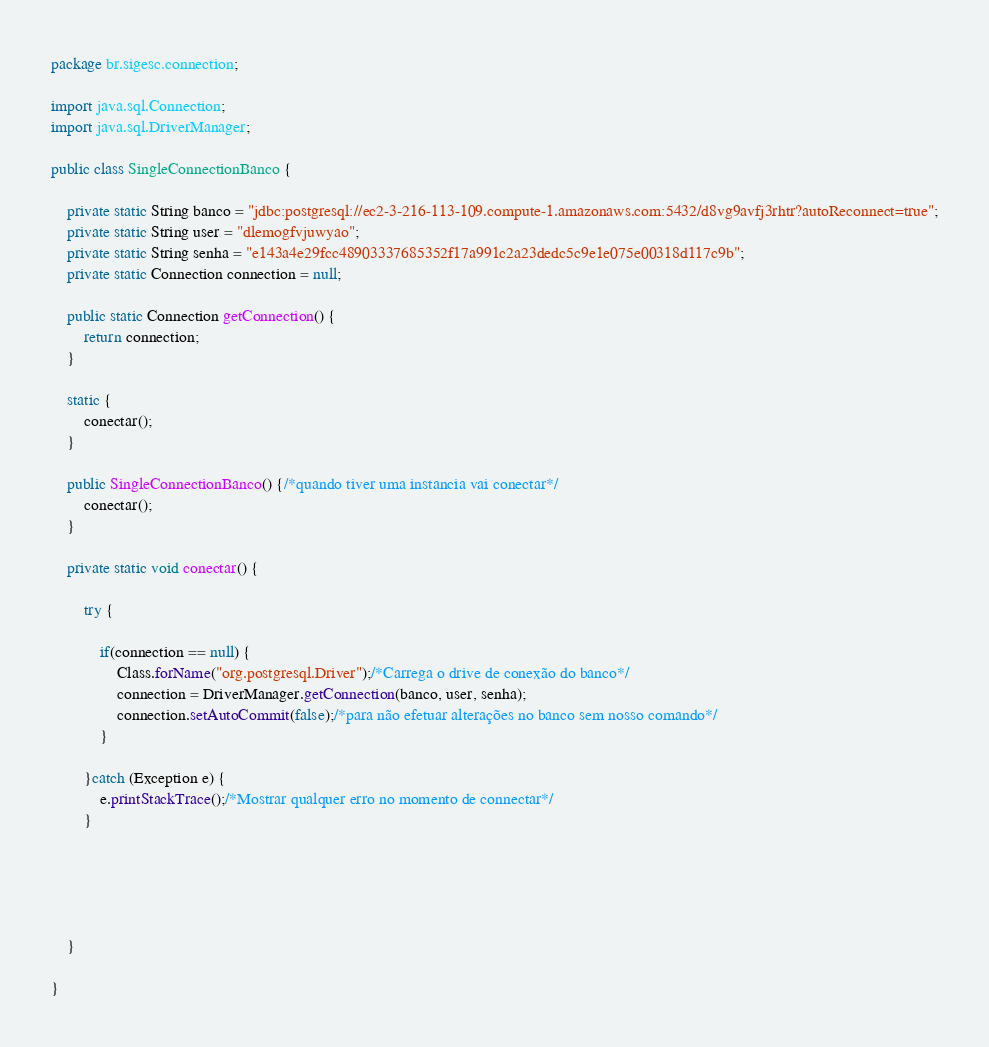<code> <loc_0><loc_0><loc_500><loc_500><_Java_>package br.sigesc.connection;

import java.sql.Connection;
import java.sql.DriverManager;

public class SingleConnectionBanco {
	
	private static String banco = "jdbc:postgresql://ec2-3-216-113-109.compute-1.amazonaws.com:5432/d8vg9avfj3rhtr?autoReconnect=true";
	private static String user = "dlemogfvjuwyao";
	private static String senha = "e143a4e29fcc48903337685352f17a991c2a23dedc5c9e1e075e00318d117c9b";
	private static Connection connection = null;
	
	public static Connection getConnection() {
		return connection;
	}
	
	static {
		conectar();
	}
	
	public SingleConnectionBanco() {/*quando tiver uma instancia vai conectar*/
		conectar();
	}
	
	private static void conectar() {
		
		try {
			
			if(connection == null) {
				Class.forName("org.postgresql.Driver");/*Carrega o drive de conexão do banco*/
				connection = DriverManager.getConnection(banco, user, senha);
				connection.setAutoCommit(false);/*para não efetuar alterações no banco sem nosso comando*/
			}
			
		}catch (Exception e) {
			e.printStackTrace();/*Mostrar qualquer erro no momento de connectar*/
		}
		
		
		
		
		
	}

}
</code> 